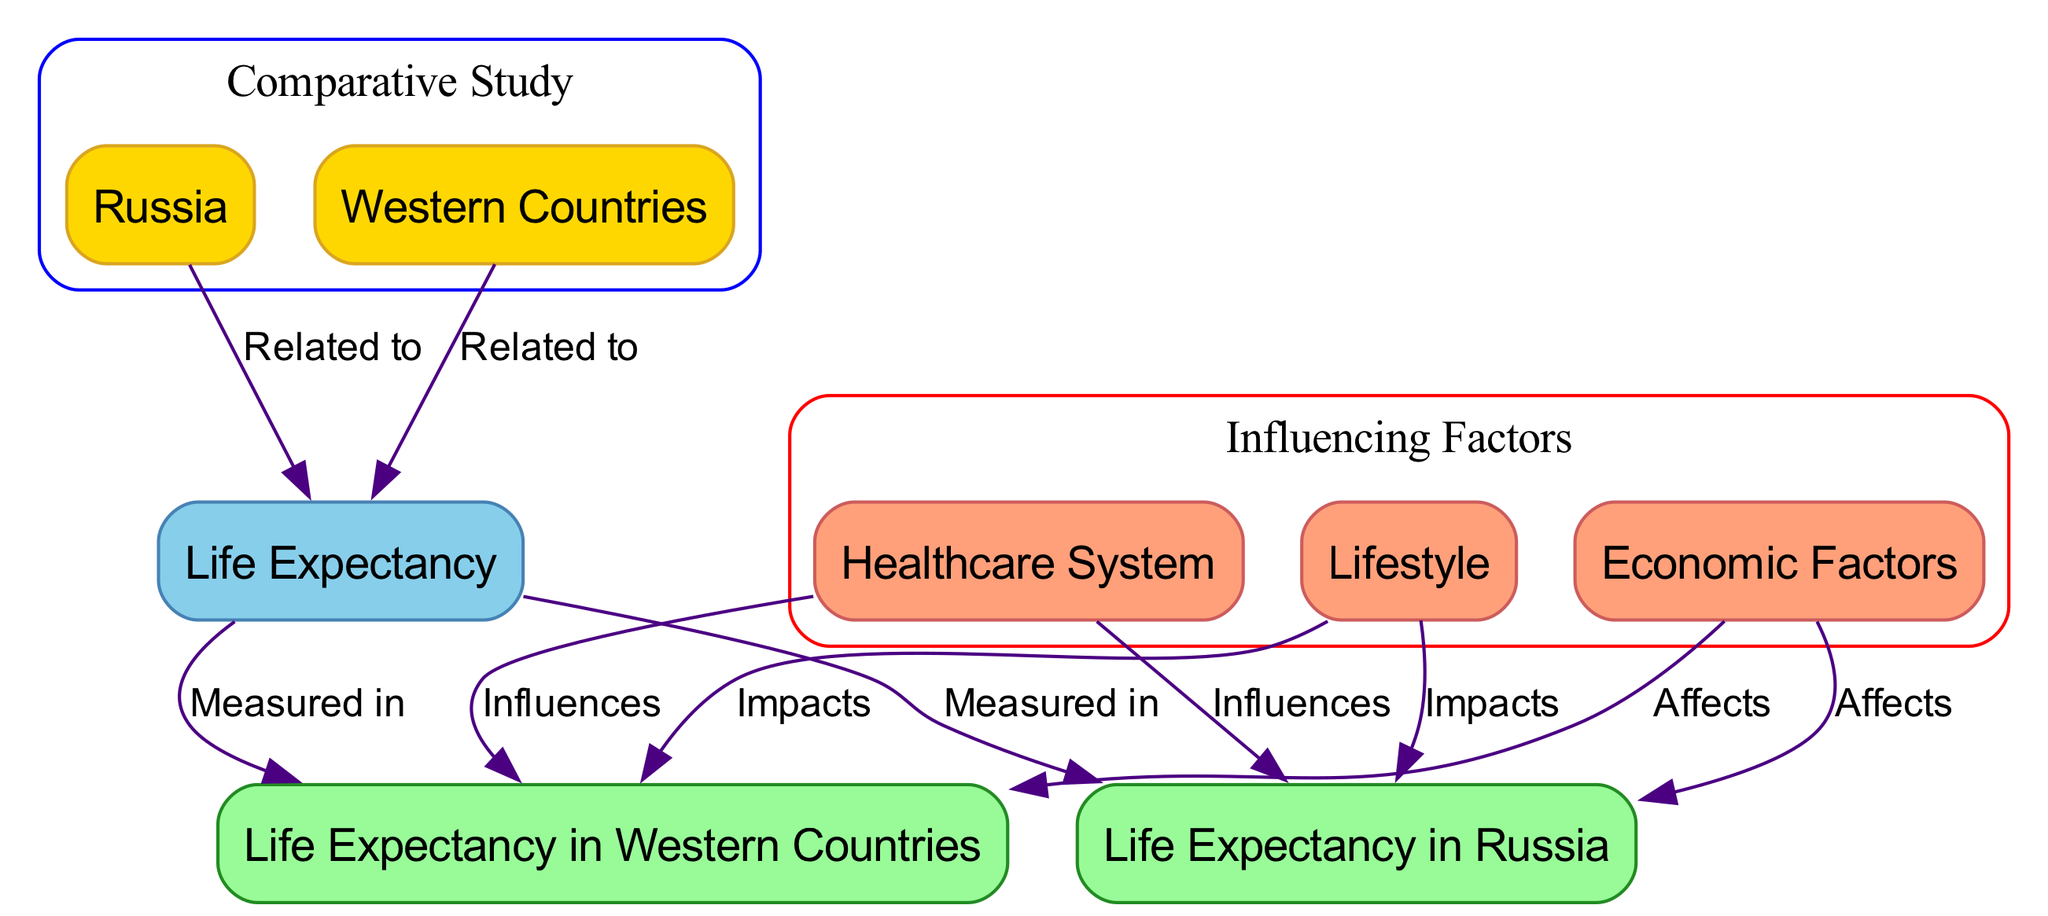What is the focus of the diagram? The diagram focuses on the "Comparative Study of Life Expectancy" between Russia and Western Countries, as indicated by the central node labeled "Comparative Study" that encloses both nodes labeled "Russia" and "Western Countries."
Answer: Comparative Study of Life Expectancy How many nodes are in the diagram? Counting the nodes, there are a total of 8 nodes: Russia, Western Countries, Life Expectancy, Healthcare System, Lifestyle, Economic Factors, Life Expectancy in Russia, and Life Expectancy in Western Countries.
Answer: 8 What influences the Life Expectancy in Russia? According to the diagram, Life Expectancy in Russia is influenced by Healthcare System, Lifestyle, and Economic Factors, which are connected to the Life Expectancy node.
Answer: Healthcare System, Lifestyle, Economic Factors Which node measures Life Expectancy in Western Countries? The node that measures Life Expectancy in Western Countries is labeled "Life Expectancy in Western Countries," which is directly connected to the main Life Expectancy node.
Answer: Life Expectancy in Western Countries What is a shared influencing factor for both Russia and Western Countries? The diagram indicates that the Healthcare System is a shared influencing factor as it influences Life Expectancy in both Russia and Western Countries.
Answer: Healthcare System How does Lifestyle impact Life Expectancy in both cases? The diagram shows that Lifestyle impacts Life Expectancy in both Russia and Western Countries, creating a connection from the Lifestyle node to both Life Expectancy in Russia and Life Expectancy in Western Countries.
Answer: Impacts both What does the edge label between Russia and Life Expectancy indicate? The edge label indicates that Russia is related to Life Expectancy, demonstrating a conceptual link between the country and the measurement of its life expectancy.
Answer: Related to What relationship exists between Economic Factors and Life Expectancy in Western Countries? The diagram illustrates that Economic Factors affect Life Expectancy in Western Countries, creating a direct connection from Economic Factors to the Life Expectancy in Western Countries node.
Answer: Affects 